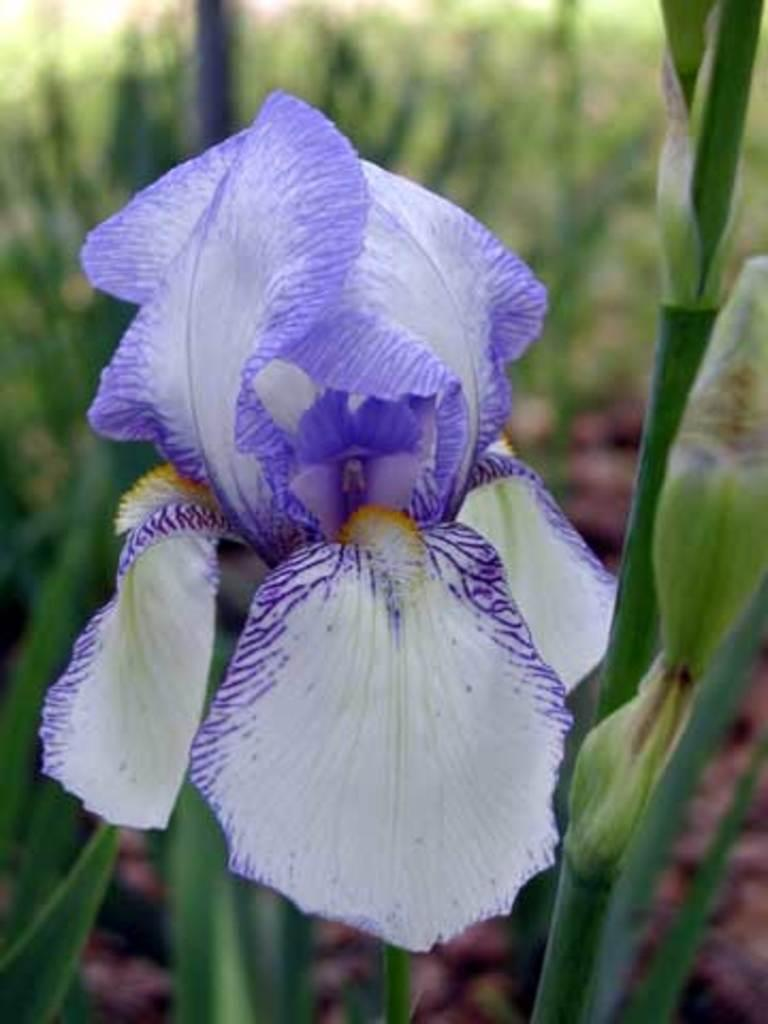What is the main subject of the image? There is a flower in the image. Can you describe the colors of the flower? The flower has white and violet colors. Where is the flower located? The flower is on a plant. How would you describe the background of the image? The background of the image is blurry. How many boats can be seen in the image? There are no boats present in the image; it features a flower on a plant. What type of clam is visible in the image? There is no clam present in the image; it features a flower on a plant. 